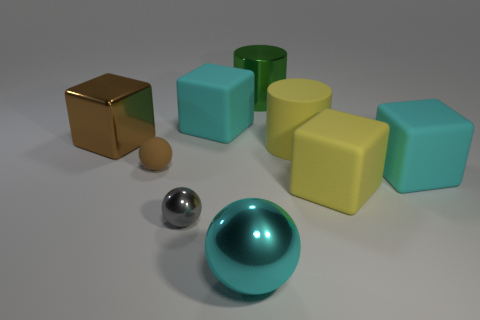Subtract all tiny gray balls. How many balls are left? 2 Subtract all yellow cylinders. How many cylinders are left? 1 Subtract all cubes. How many objects are left? 5 Subtract 1 cylinders. How many cylinders are left? 1 Add 2 shiny objects. How many shiny objects exist? 6 Add 1 tiny balls. How many objects exist? 10 Subtract 0 blue cubes. How many objects are left? 9 Subtract all gray cylinders. Subtract all green blocks. How many cylinders are left? 2 Subtract all gray cylinders. How many red balls are left? 0 Subtract all big cyan matte objects. Subtract all rubber cylinders. How many objects are left? 6 